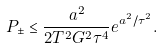Convert formula to latex. <formula><loc_0><loc_0><loc_500><loc_500>P _ { \pm } \leq \frac { a ^ { 2 } } { 2 T ^ { 2 } G ^ { 2 } \tau ^ { 4 } } e ^ { a ^ { 2 } / \tau ^ { 2 } } .</formula> 